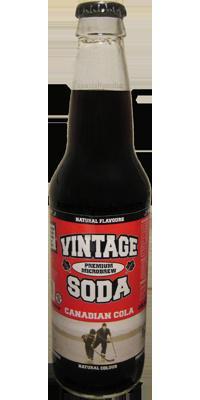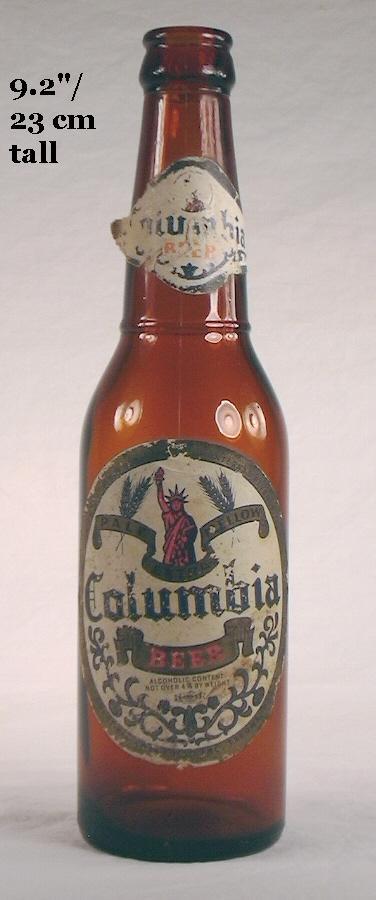The first image is the image on the left, the second image is the image on the right. Analyze the images presented: Is the assertion "One bottle is capped and one is not, at least one bottle is brown glass, at least one bottle is empty, and all bottles are beverage bottles." valid? Answer yes or no. Yes. The first image is the image on the left, the second image is the image on the right. Considering the images on both sides, is "there is an amber colored empty bottle with no cap on" valid? Answer yes or no. Yes. 